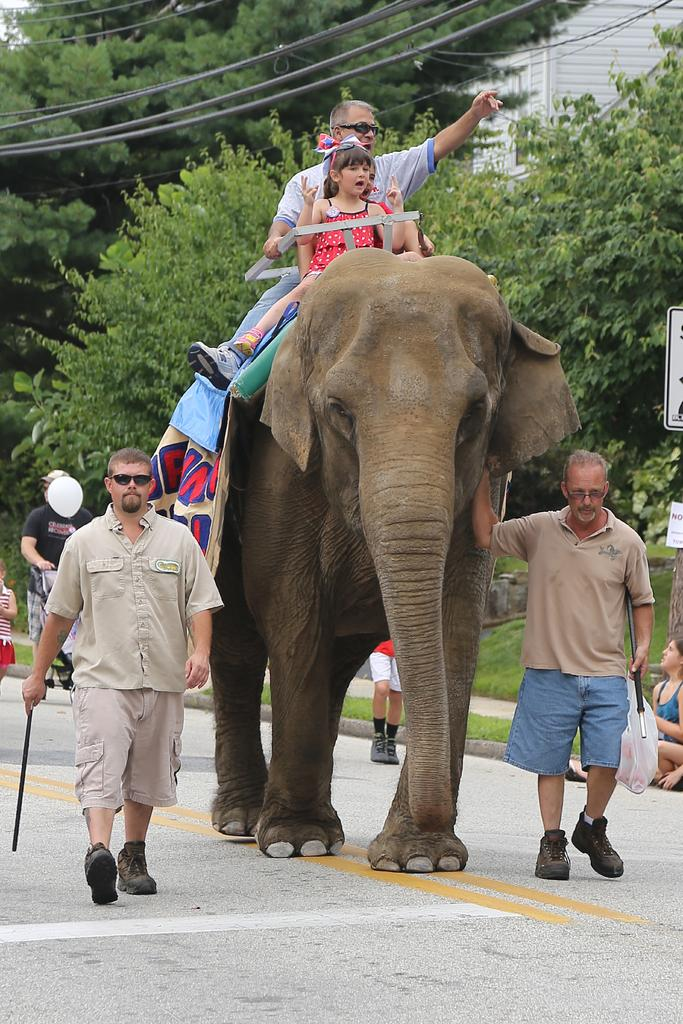What animal is present in the image? There is an elephant in the image. How many people are on the elephant? Two persons are sitting on the elephant. What are the people in the image doing? One person is walking, and another person is walking. What can be seen in the background of the image? There are trees and a building in the background of the image. What else is visible in the image? There are cables visible in the image. What type of expert can be seen dusting the mountain in the image? There is no expert, dust, or mountain present in the image. 